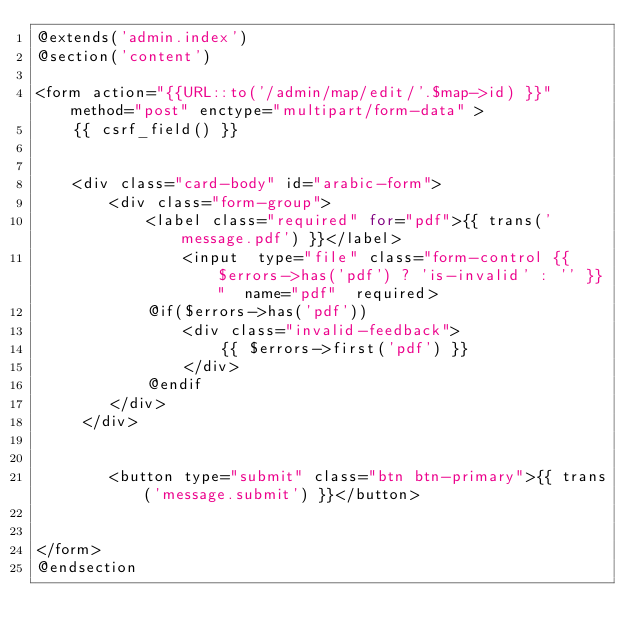<code> <loc_0><loc_0><loc_500><loc_500><_PHP_>@extends('admin.index')
@section('content')

<form action="{{URL::to('/admin/map/edit/'.$map->id) }}" method="post" enctype="multipart/form-data" >
    {{ csrf_field() }}


    <div class="card-body" id="arabic-form">
        <div class="form-group">
            <label class="required" for="pdf">{{ trans('message.pdf') }}</label>
                <input  type="file" class="form-control {{ $errors->has('pdf') ? 'is-invalid' : '' }}"  name="pdf"  required>
            @if($errors->has('pdf'))
                <div class="invalid-feedback">
                    {{ $errors->first('pdf') }}
                </div>
            @endif
        </div>
     </div>


        <button type="submit" class="btn btn-primary">{{ trans('message.submit') }}</button>


</form>
@endsection
</code> 